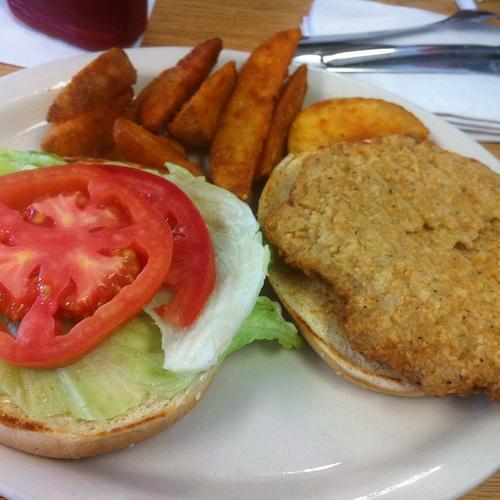How many tomatoes are there?
Give a very brief answer. 2. 